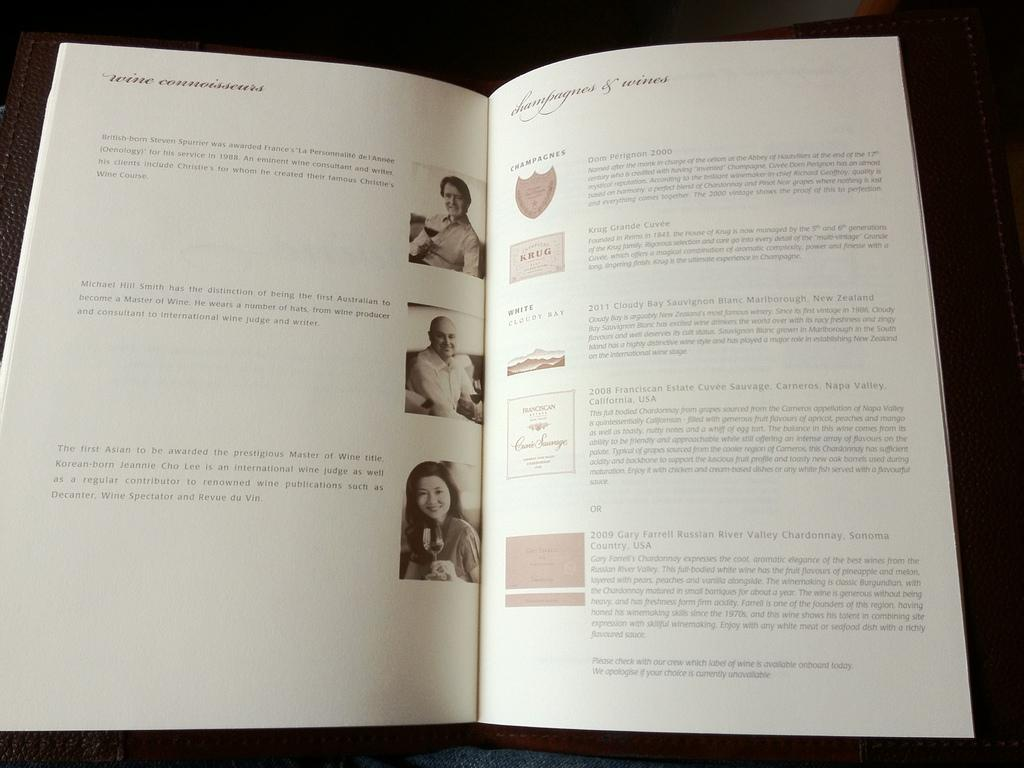<image>
Present a compact description of the photo's key features. A book is open to a page that says wine connoisseurs. 